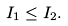Convert formula to latex. <formula><loc_0><loc_0><loc_500><loc_500>I _ { 1 } \leq I _ { 2 } .</formula> 